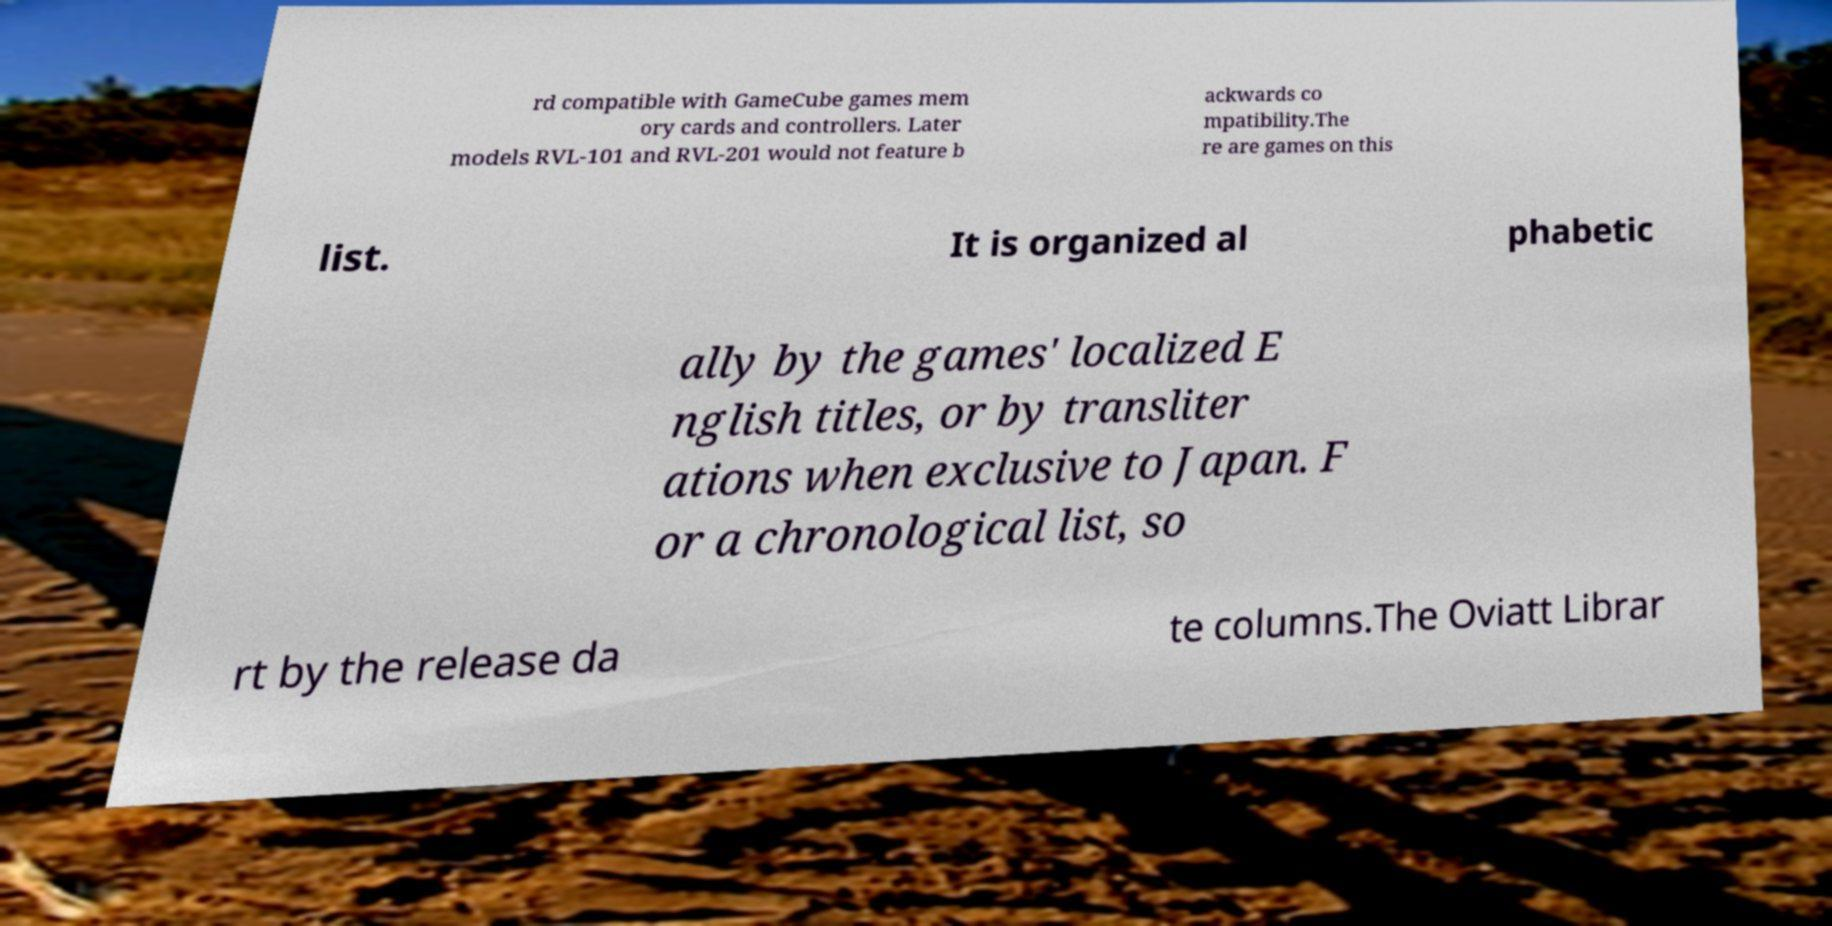What messages or text are displayed in this image? I need them in a readable, typed format. rd compatible with GameCube games mem ory cards and controllers. Later models RVL-101 and RVL-201 would not feature b ackwards co mpatibility.The re are games on this list. It is organized al phabetic ally by the games' localized E nglish titles, or by transliter ations when exclusive to Japan. F or a chronological list, so rt by the release da te columns.The Oviatt Librar 